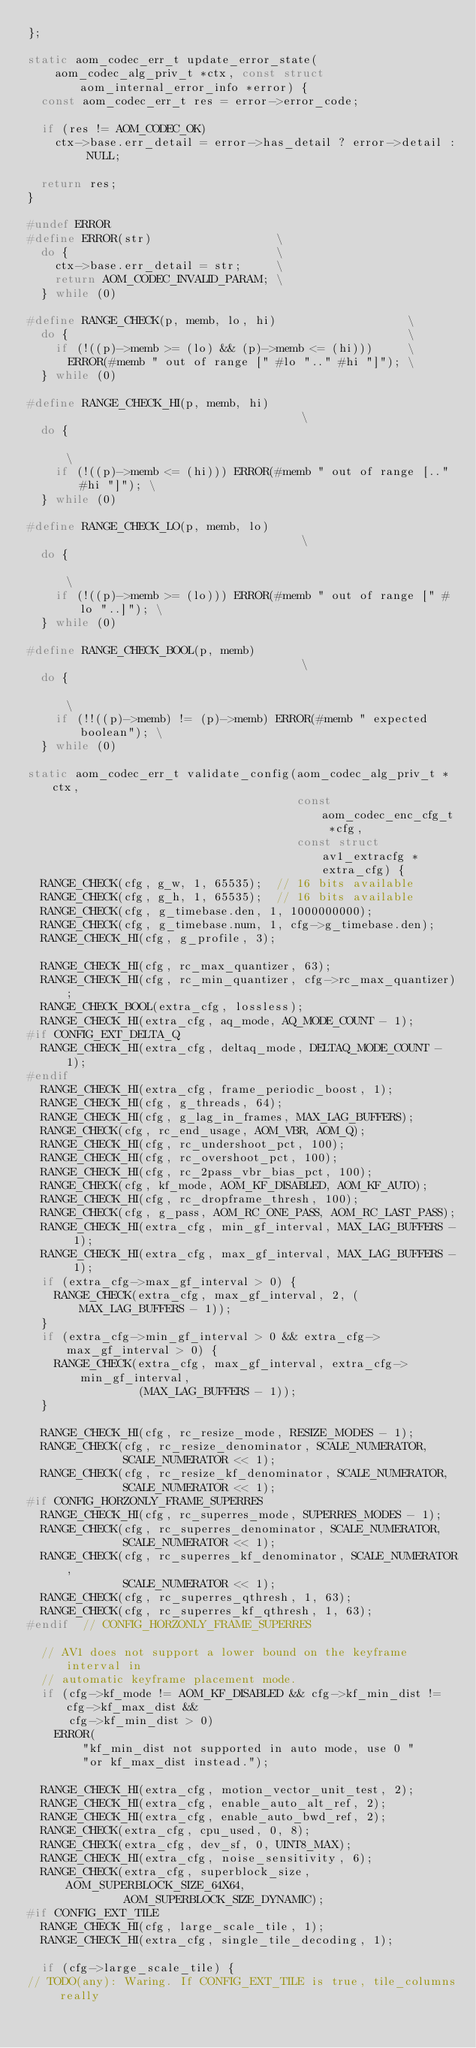<code> <loc_0><loc_0><loc_500><loc_500><_C_>};

static aom_codec_err_t update_error_state(
    aom_codec_alg_priv_t *ctx, const struct aom_internal_error_info *error) {
  const aom_codec_err_t res = error->error_code;

  if (res != AOM_CODEC_OK)
    ctx->base.err_detail = error->has_detail ? error->detail : NULL;

  return res;
}

#undef ERROR
#define ERROR(str)                  \
  do {                              \
    ctx->base.err_detail = str;     \
    return AOM_CODEC_INVALID_PARAM; \
  } while (0)

#define RANGE_CHECK(p, memb, lo, hi)                   \
  do {                                                 \
    if (!((p)->memb >= (lo) && (p)->memb <= (hi)))     \
      ERROR(#memb " out of range [" #lo ".." #hi "]"); \
  } while (0)

#define RANGE_CHECK_HI(p, memb, hi)                                     \
  do {                                                                  \
    if (!((p)->memb <= (hi))) ERROR(#memb " out of range [.." #hi "]"); \
  } while (0)

#define RANGE_CHECK_LO(p, memb, lo)                                     \
  do {                                                                  \
    if (!((p)->memb >= (lo))) ERROR(#memb " out of range [" #lo "..]"); \
  } while (0)

#define RANGE_CHECK_BOOL(p, memb)                                     \
  do {                                                                \
    if (!!((p)->memb) != (p)->memb) ERROR(#memb " expected boolean"); \
  } while (0)

static aom_codec_err_t validate_config(aom_codec_alg_priv_t *ctx,
                                       const aom_codec_enc_cfg_t *cfg,
                                       const struct av1_extracfg *extra_cfg) {
  RANGE_CHECK(cfg, g_w, 1, 65535);  // 16 bits available
  RANGE_CHECK(cfg, g_h, 1, 65535);  // 16 bits available
  RANGE_CHECK(cfg, g_timebase.den, 1, 1000000000);
  RANGE_CHECK(cfg, g_timebase.num, 1, cfg->g_timebase.den);
  RANGE_CHECK_HI(cfg, g_profile, 3);

  RANGE_CHECK_HI(cfg, rc_max_quantizer, 63);
  RANGE_CHECK_HI(cfg, rc_min_quantizer, cfg->rc_max_quantizer);
  RANGE_CHECK_BOOL(extra_cfg, lossless);
  RANGE_CHECK_HI(extra_cfg, aq_mode, AQ_MODE_COUNT - 1);
#if CONFIG_EXT_DELTA_Q
  RANGE_CHECK_HI(extra_cfg, deltaq_mode, DELTAQ_MODE_COUNT - 1);
#endif
  RANGE_CHECK_HI(extra_cfg, frame_periodic_boost, 1);
  RANGE_CHECK_HI(cfg, g_threads, 64);
  RANGE_CHECK_HI(cfg, g_lag_in_frames, MAX_LAG_BUFFERS);
  RANGE_CHECK(cfg, rc_end_usage, AOM_VBR, AOM_Q);
  RANGE_CHECK_HI(cfg, rc_undershoot_pct, 100);
  RANGE_CHECK_HI(cfg, rc_overshoot_pct, 100);
  RANGE_CHECK_HI(cfg, rc_2pass_vbr_bias_pct, 100);
  RANGE_CHECK(cfg, kf_mode, AOM_KF_DISABLED, AOM_KF_AUTO);
  RANGE_CHECK_HI(cfg, rc_dropframe_thresh, 100);
  RANGE_CHECK(cfg, g_pass, AOM_RC_ONE_PASS, AOM_RC_LAST_PASS);
  RANGE_CHECK_HI(extra_cfg, min_gf_interval, MAX_LAG_BUFFERS - 1);
  RANGE_CHECK_HI(extra_cfg, max_gf_interval, MAX_LAG_BUFFERS - 1);
  if (extra_cfg->max_gf_interval > 0) {
    RANGE_CHECK(extra_cfg, max_gf_interval, 2, (MAX_LAG_BUFFERS - 1));
  }
  if (extra_cfg->min_gf_interval > 0 && extra_cfg->max_gf_interval > 0) {
    RANGE_CHECK(extra_cfg, max_gf_interval, extra_cfg->min_gf_interval,
                (MAX_LAG_BUFFERS - 1));
  }

  RANGE_CHECK_HI(cfg, rc_resize_mode, RESIZE_MODES - 1);
  RANGE_CHECK(cfg, rc_resize_denominator, SCALE_NUMERATOR,
              SCALE_NUMERATOR << 1);
  RANGE_CHECK(cfg, rc_resize_kf_denominator, SCALE_NUMERATOR,
              SCALE_NUMERATOR << 1);
#if CONFIG_HORZONLY_FRAME_SUPERRES
  RANGE_CHECK_HI(cfg, rc_superres_mode, SUPERRES_MODES - 1);
  RANGE_CHECK(cfg, rc_superres_denominator, SCALE_NUMERATOR,
              SCALE_NUMERATOR << 1);
  RANGE_CHECK(cfg, rc_superres_kf_denominator, SCALE_NUMERATOR,
              SCALE_NUMERATOR << 1);
  RANGE_CHECK(cfg, rc_superres_qthresh, 1, 63);
  RANGE_CHECK(cfg, rc_superres_kf_qthresh, 1, 63);
#endif  // CONFIG_HORZONLY_FRAME_SUPERRES

  // AV1 does not support a lower bound on the keyframe interval in
  // automatic keyframe placement mode.
  if (cfg->kf_mode != AOM_KF_DISABLED && cfg->kf_min_dist != cfg->kf_max_dist &&
      cfg->kf_min_dist > 0)
    ERROR(
        "kf_min_dist not supported in auto mode, use 0 "
        "or kf_max_dist instead.");

  RANGE_CHECK_HI(extra_cfg, motion_vector_unit_test, 2);
  RANGE_CHECK_HI(extra_cfg, enable_auto_alt_ref, 2);
  RANGE_CHECK_HI(extra_cfg, enable_auto_bwd_ref, 2);
  RANGE_CHECK(extra_cfg, cpu_used, 0, 8);
  RANGE_CHECK(extra_cfg, dev_sf, 0, UINT8_MAX);
  RANGE_CHECK_HI(extra_cfg, noise_sensitivity, 6);
  RANGE_CHECK(extra_cfg, superblock_size, AOM_SUPERBLOCK_SIZE_64X64,
              AOM_SUPERBLOCK_SIZE_DYNAMIC);
#if CONFIG_EXT_TILE
  RANGE_CHECK_HI(cfg, large_scale_tile, 1);
  RANGE_CHECK_HI(extra_cfg, single_tile_decoding, 1);

  if (cfg->large_scale_tile) {
// TODO(any): Waring. If CONFIG_EXT_TILE is true, tile_columns really</code> 